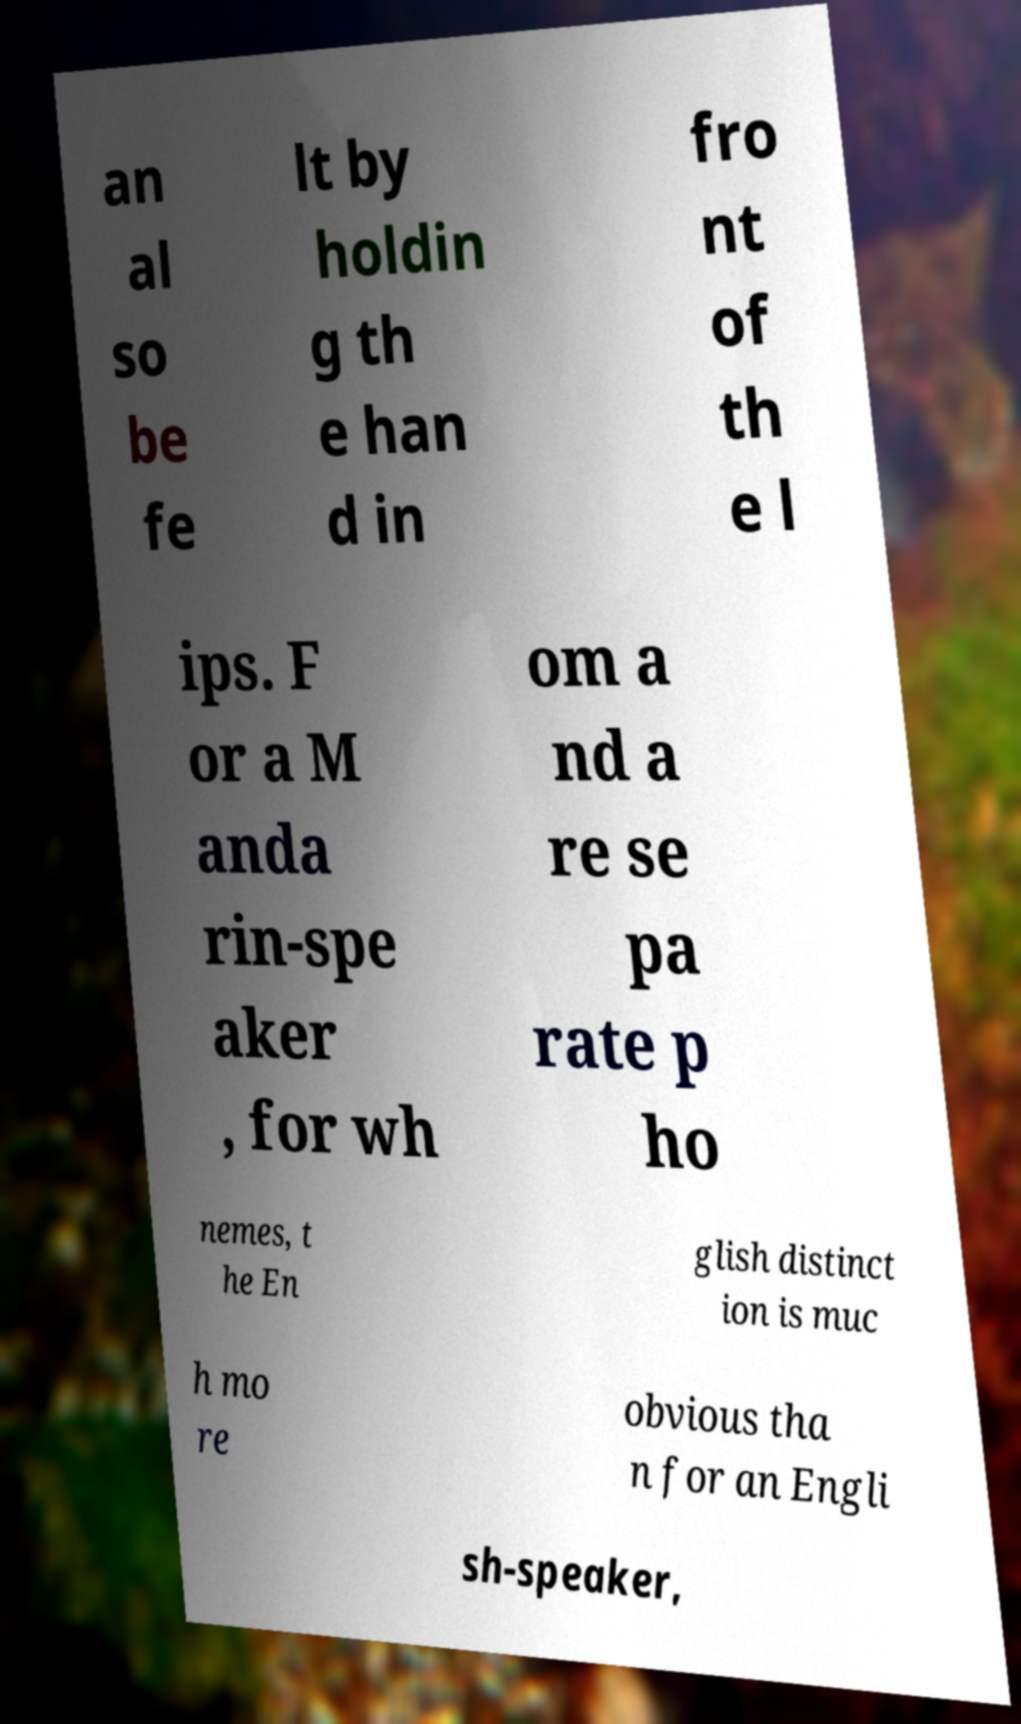Please read and relay the text visible in this image. What does it say? an al so be fe lt by holdin g th e han d in fro nt of th e l ips. F or a M anda rin-spe aker , for wh om a nd a re se pa rate p ho nemes, t he En glish distinct ion is muc h mo re obvious tha n for an Engli sh-speaker, 